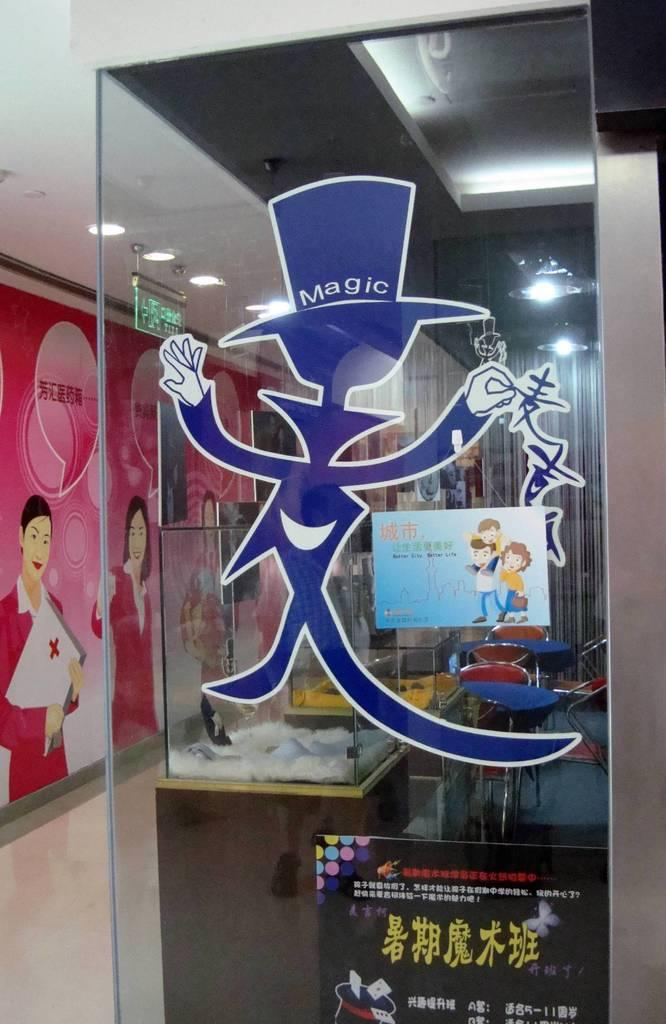Provide a one-sentence caption for the provided image. A glass panel with a blue magician on the front of it with Magic written on his hat. 